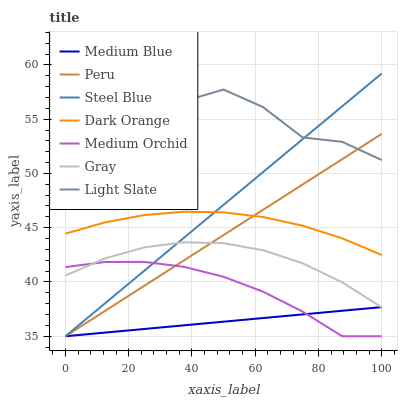Does Medium Blue have the minimum area under the curve?
Answer yes or no. Yes. Does Light Slate have the maximum area under the curve?
Answer yes or no. Yes. Does Gray have the minimum area under the curve?
Answer yes or no. No. Does Gray have the maximum area under the curve?
Answer yes or no. No. Is Peru the smoothest?
Answer yes or no. Yes. Is Light Slate the roughest?
Answer yes or no. Yes. Is Gray the smoothest?
Answer yes or no. No. Is Gray the roughest?
Answer yes or no. No. Does Medium Orchid have the lowest value?
Answer yes or no. Yes. Does Gray have the lowest value?
Answer yes or no. No. Does Light Slate have the highest value?
Answer yes or no. Yes. Does Gray have the highest value?
Answer yes or no. No. Is Dark Orange less than Light Slate?
Answer yes or no. Yes. Is Dark Orange greater than Gray?
Answer yes or no. Yes. Does Peru intersect Light Slate?
Answer yes or no. Yes. Is Peru less than Light Slate?
Answer yes or no. No. Is Peru greater than Light Slate?
Answer yes or no. No. Does Dark Orange intersect Light Slate?
Answer yes or no. No. 